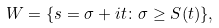<formula> <loc_0><loc_0><loc_500><loc_500>W = \{ s = \sigma + i t \colon \sigma \geq S ( t ) \} ,</formula> 